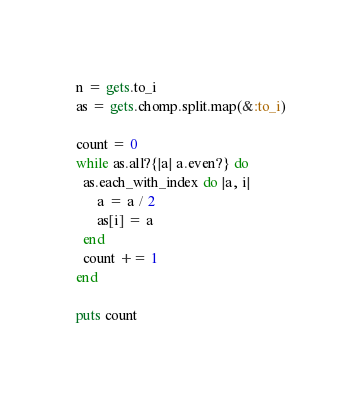Convert code to text. <code><loc_0><loc_0><loc_500><loc_500><_Ruby_>n = gets.to_i
as = gets.chomp.split.map(&:to_i)

count = 0
while as.all?{|a| a.even?} do
  as.each_with_index do |a, i|
      a = a / 2
      as[i] = a
  end
  count += 1
end

puts count</code> 